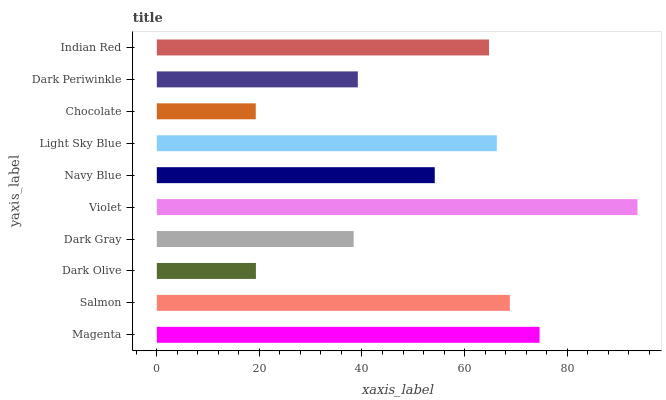Is Chocolate the minimum?
Answer yes or no. Yes. Is Violet the maximum?
Answer yes or no. Yes. Is Salmon the minimum?
Answer yes or no. No. Is Salmon the maximum?
Answer yes or no. No. Is Magenta greater than Salmon?
Answer yes or no. Yes. Is Salmon less than Magenta?
Answer yes or no. Yes. Is Salmon greater than Magenta?
Answer yes or no. No. Is Magenta less than Salmon?
Answer yes or no. No. Is Indian Red the high median?
Answer yes or no. Yes. Is Navy Blue the low median?
Answer yes or no. Yes. Is Magenta the high median?
Answer yes or no. No. Is Magenta the low median?
Answer yes or no. No. 